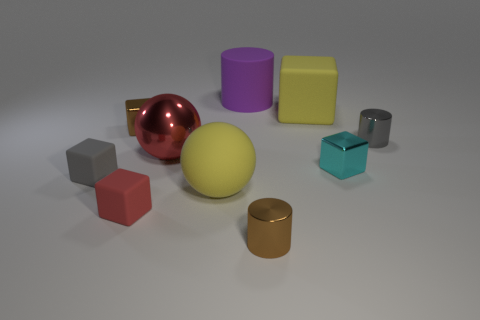Do the cyan metal object and the rubber cube that is right of the big rubber sphere have the same size?
Your answer should be compact. No. What size is the red thing that is in front of the large sphere that is left of the large yellow rubber object that is to the left of the purple cylinder?
Ensure brevity in your answer.  Small. There is a small brown metallic cube; what number of small metal cylinders are right of it?
Make the answer very short. 2. There is a big thing that is behind the large yellow matte thing that is to the right of the purple matte cylinder; what is its material?
Offer a terse response. Rubber. Is there anything else that has the same size as the rubber sphere?
Provide a succinct answer. Yes. Do the brown cylinder and the cyan cube have the same size?
Offer a terse response. Yes. What number of objects are either large yellow rubber objects that are right of the large cylinder or tiny rubber things to the left of the brown block?
Your answer should be very brief. 2. Is the number of cylinders in front of the shiny ball greater than the number of large blue metal cubes?
Your answer should be very brief. Yes. How many other objects are there of the same shape as the tiny red thing?
Offer a terse response. 4. What is the material of the block that is both behind the small cyan block and right of the brown cylinder?
Give a very brief answer. Rubber. 